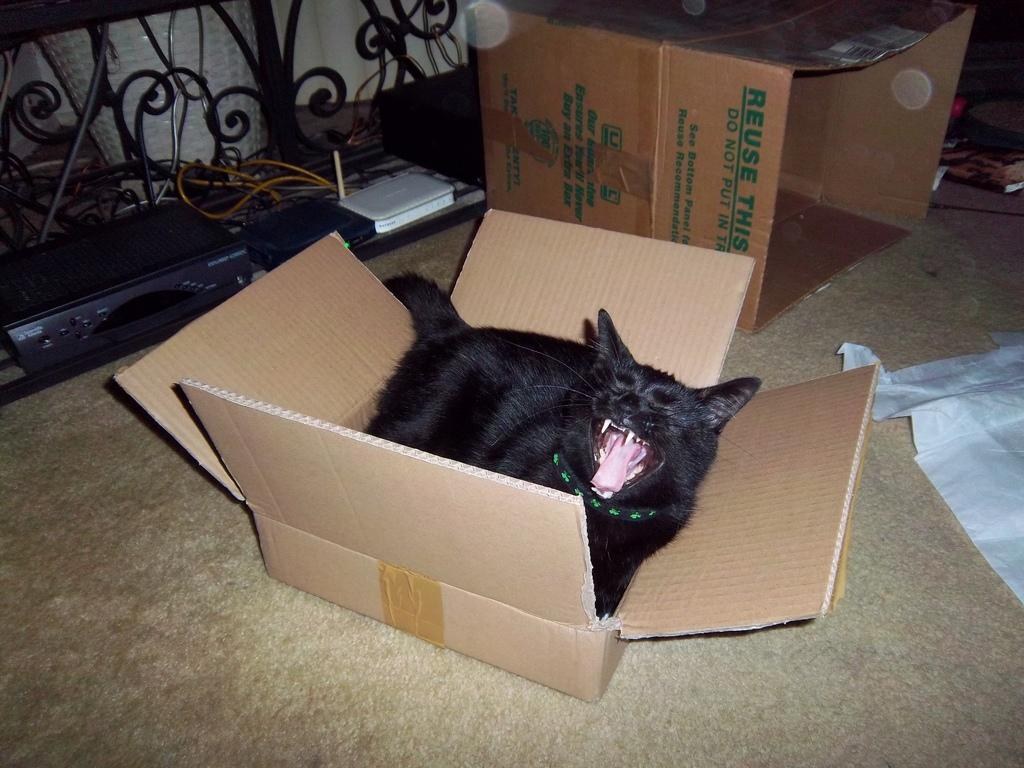<image>
Give a short and clear explanation of the subsequent image. A cardboard box that says Reuse This on it is on the floor. 